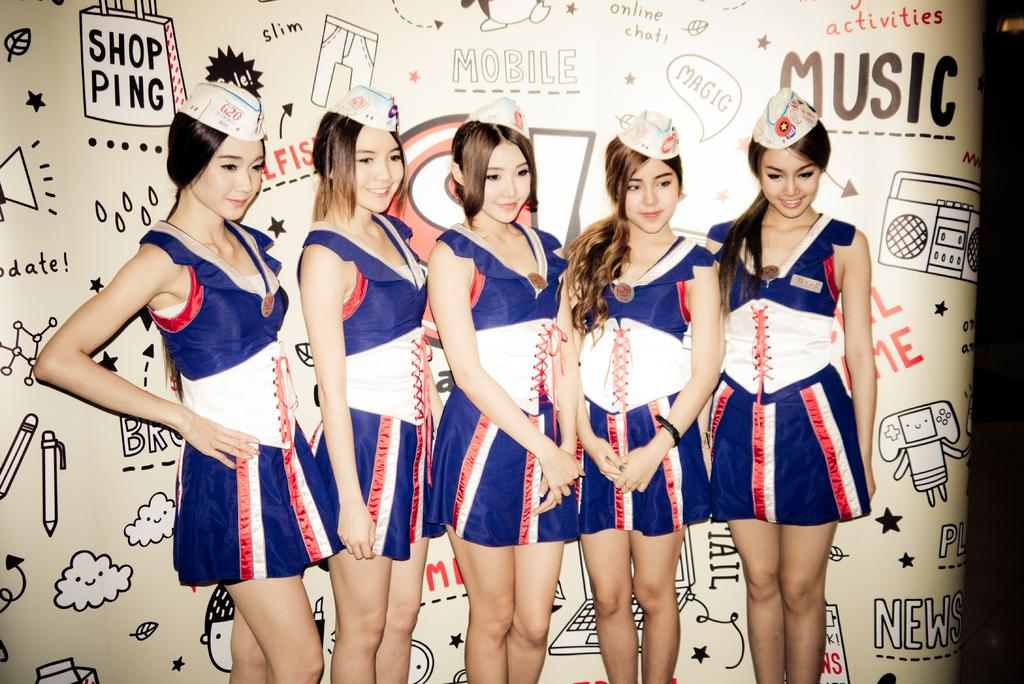<image>
Offer a succinct explanation of the picture presented. A group of young women all posing for a picture in front of a giant wall with words like music and shop ping writ tin upon it. 